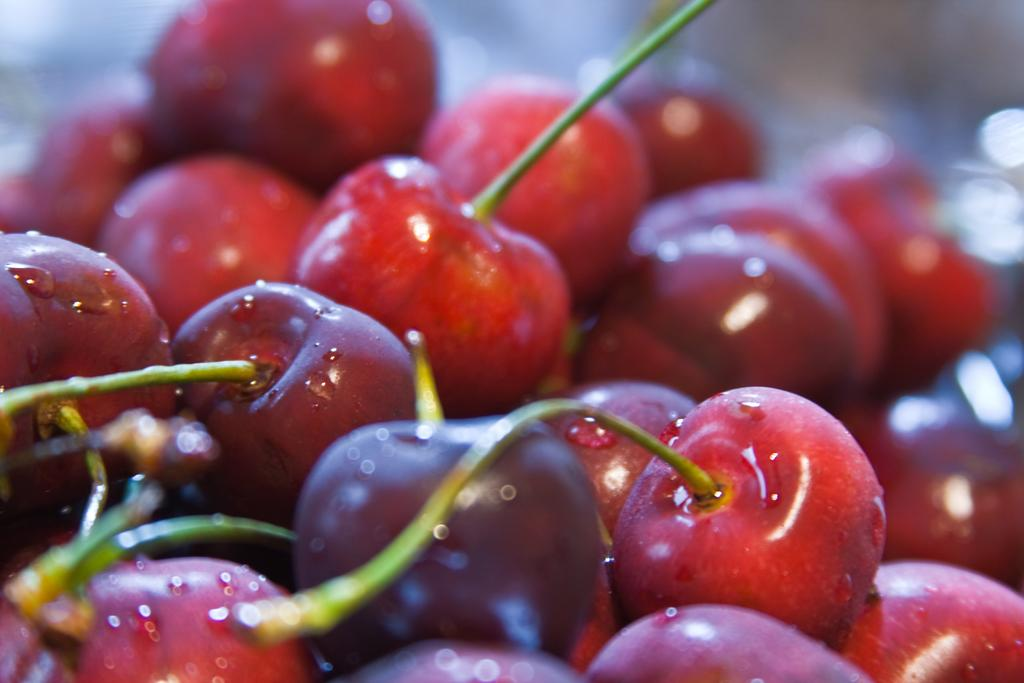What type of fruit is featured in the image? There is a bunch of cherries in the image. What can be observed about the stems of the cherries? The stems of the cherries are green in color. What grade does the society give to the cherries in the image? There is no mention of a society or a grade in the image, as it only features a bunch of cherries with green stems. 